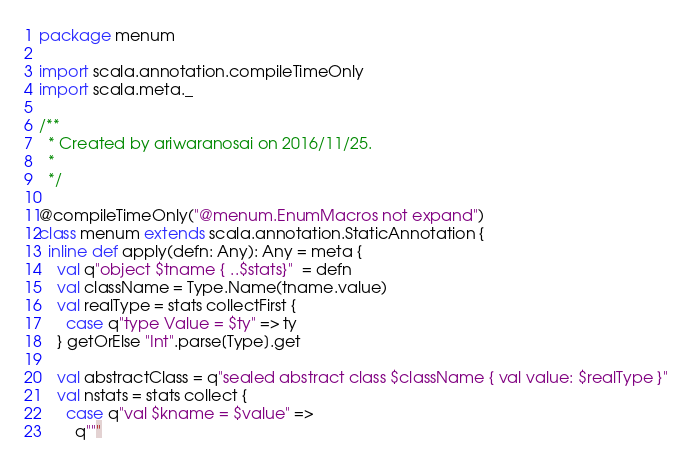Convert code to text. <code><loc_0><loc_0><loc_500><loc_500><_Scala_>package menum

import scala.annotation.compileTimeOnly
import scala.meta._

/**
  * Created by ariwaranosai on 2016/11/25.
  *
  */

@compileTimeOnly("@menum.EnumMacros not expand")
class menum extends scala.annotation.StaticAnnotation {
  inline def apply(defn: Any): Any = meta {
    val q"object $tname { ..$stats}"  = defn
    val className = Type.Name(tname.value)
    val realType = stats collectFirst {
      case q"type Value = $ty" => ty
    } getOrElse "Int".parse[Type].get

    val abstractClass = q"sealed abstract class $className { val value: $realType }"
    val nstats = stats collect {
      case q"val $kname = $value" =>
        q"""</code> 